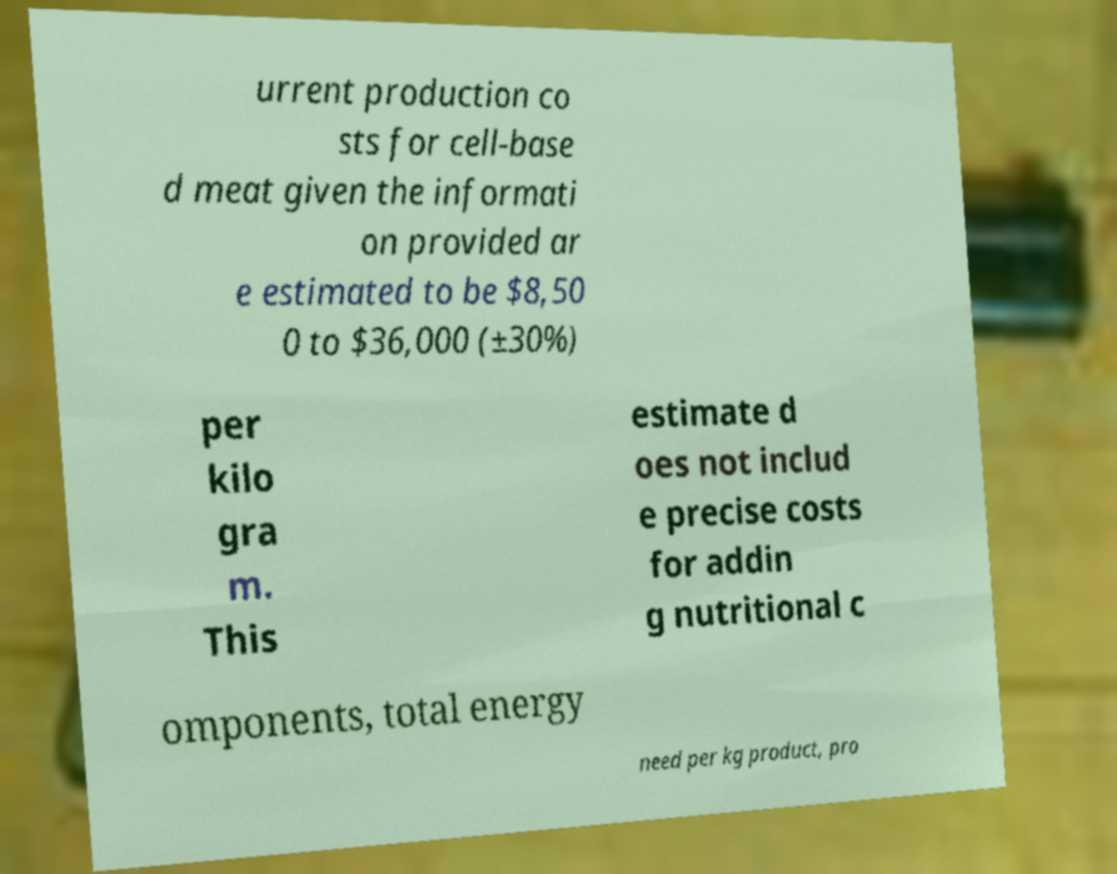Could you assist in decoding the text presented in this image and type it out clearly? urrent production co sts for cell-base d meat given the informati on provided ar e estimated to be $8,50 0 to $36,000 (±30%) per kilo gra m. This estimate d oes not includ e precise costs for addin g nutritional c omponents, total energy need per kg product, pro 